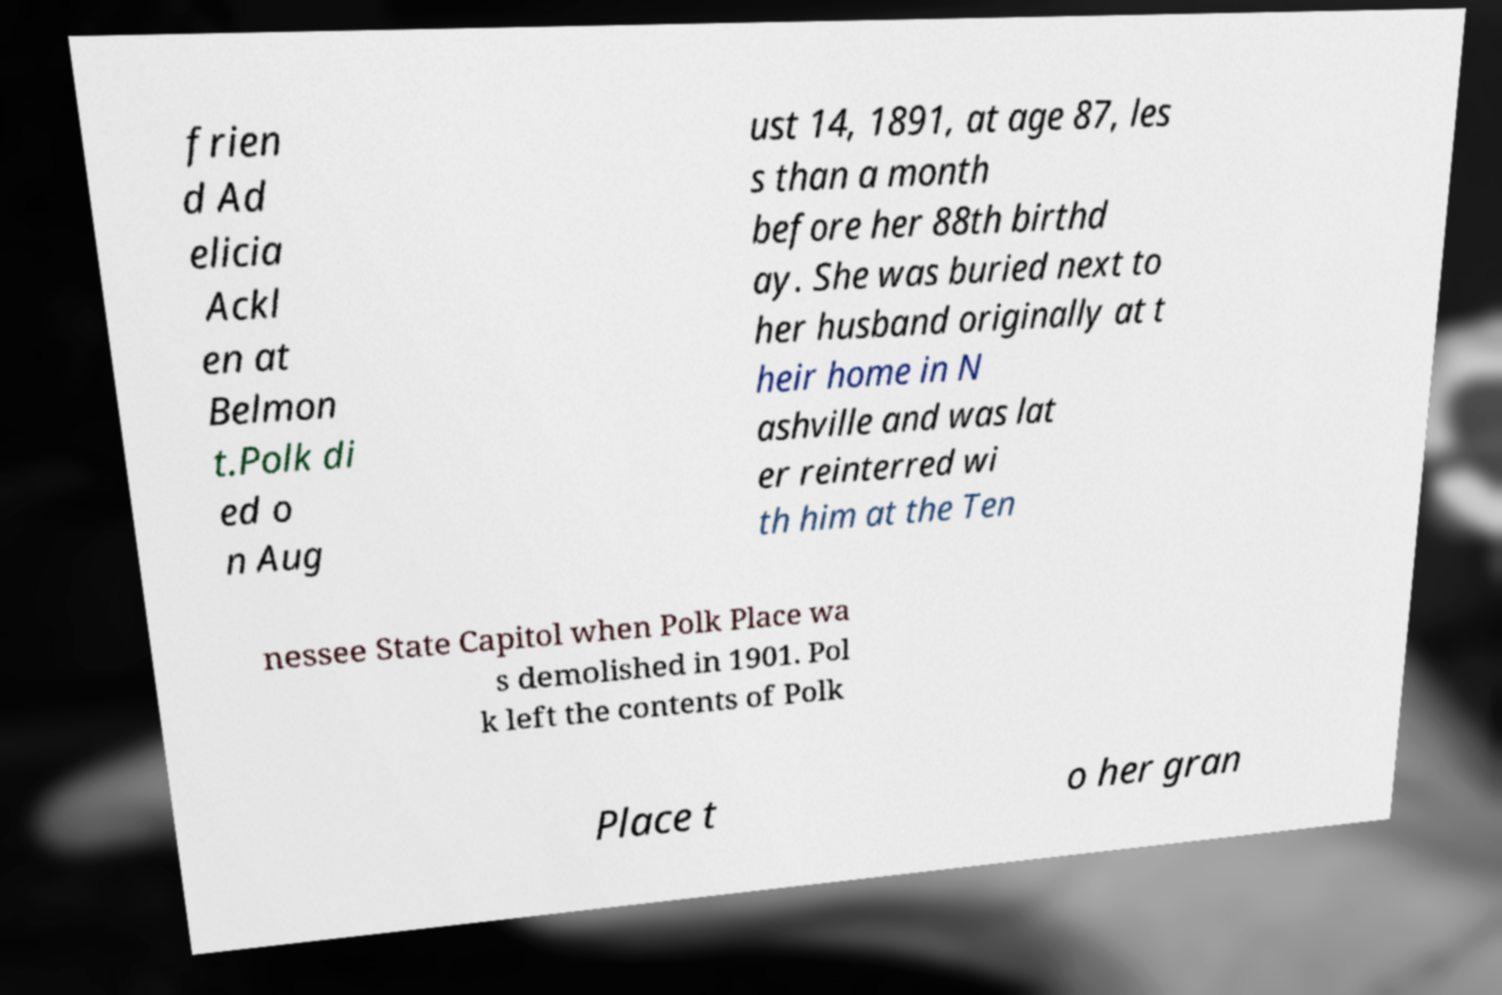Can you accurately transcribe the text from the provided image for me? frien d Ad elicia Ackl en at Belmon t.Polk di ed o n Aug ust 14, 1891, at age 87, les s than a month before her 88th birthd ay. She was buried next to her husband originally at t heir home in N ashville and was lat er reinterred wi th him at the Ten nessee State Capitol when Polk Place wa s demolished in 1901. Pol k left the contents of Polk Place t o her gran 